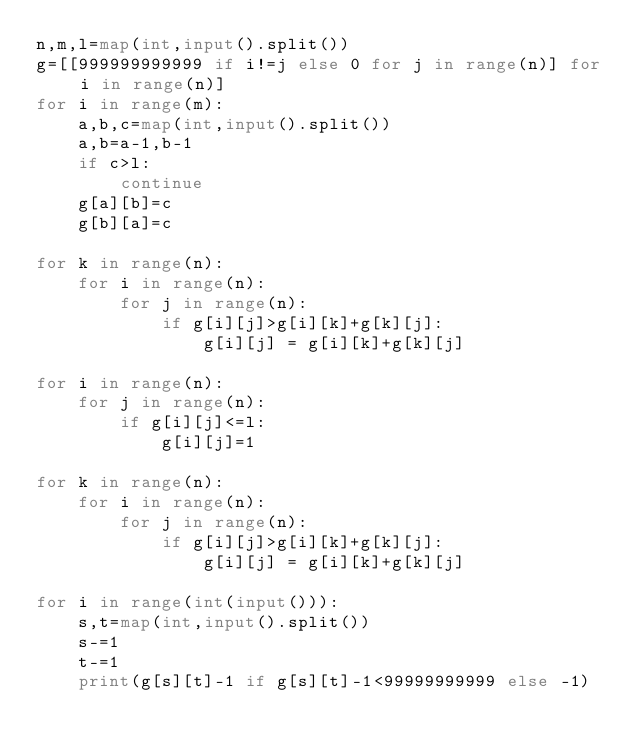Convert code to text. <code><loc_0><loc_0><loc_500><loc_500><_Python_>n,m,l=map(int,input().split())
g=[[999999999999 if i!=j else 0 for j in range(n)] for i in range(n)]
for i in range(m):
    a,b,c=map(int,input().split())
    a,b=a-1,b-1
    if c>l:
        continue
    g[a][b]=c
    g[b][a]=c

for k in range(n):
    for i in range(n):
        for j in range(n):
            if g[i][j]>g[i][k]+g[k][j]:
                g[i][j] = g[i][k]+g[k][j]

for i in range(n):
    for j in range(n):
        if g[i][j]<=l:
            g[i][j]=1

for k in range(n):
    for i in range(n):
        for j in range(n):
            if g[i][j]>g[i][k]+g[k][j]:
                g[i][j] = g[i][k]+g[k][j]

for i in range(int(input())):
    s,t=map(int,input().split())
    s-=1
    t-=1
    print(g[s][t]-1 if g[s][t]-1<99999999999 else -1)

</code> 